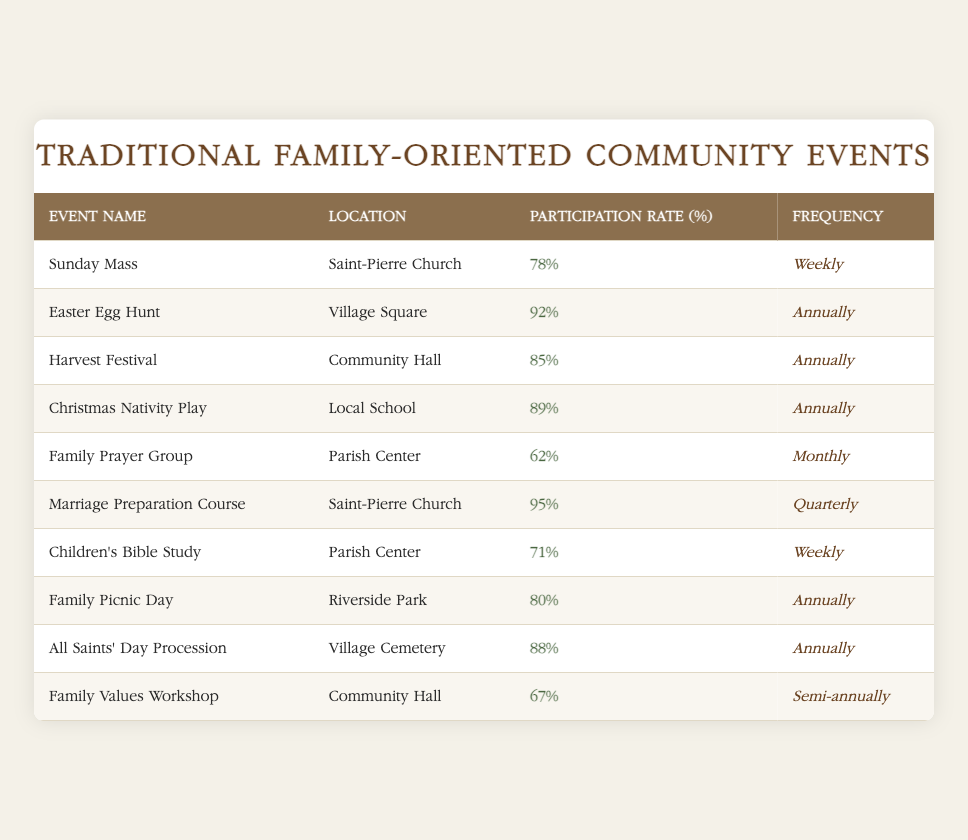What is the participation rate for the Marriage Preparation Course? The table shows that the participation rate for the Marriage Preparation Course is listed under the "Participation Rate (%)" column for that event. It is 95%.
Answer: 95% Which event has the lowest participation rate? By looking at the "Participation Rate (%)" column, the lowest number is listed for the Family Prayer Group at 62%, making it the event with the lowest participation rate.
Answer: Family Prayer Group How many events have a participation rate above 80%? To find this, I check the participation rates for each event. The events with rates above 80% are Easter Egg Hunt (92%), Harvest Festival (85%), Christmas Nativity Play (89%), Marriage Preparation Course (95%), Family Picnic Day (80%), and All Saints' Day Procession (88%). There are a total of 6 events above 80%.
Answer: 6 Is the Family Values Workshop held more frequently than the Sunday Mass? The Family Values Workshop is held semi-annually while Sunday Mass is held weekly. Since semi-annually occurs less frequently than weekly, the answer is no.
Answer: No What is the average participation rate of events held annually? The events held annually are Easter Egg Hunt (92%), Harvest Festival (85%), Christmas Nativity Play (89%), Family Picnic Day (80%), and All Saints' Day Procession (88%). To find the average, I sum these rates: 92 + 85 + 89 + 80 + 88 = 434. There are 5 events, so the average is 434 / 5 = 86.8%.
Answer: 86.8% 